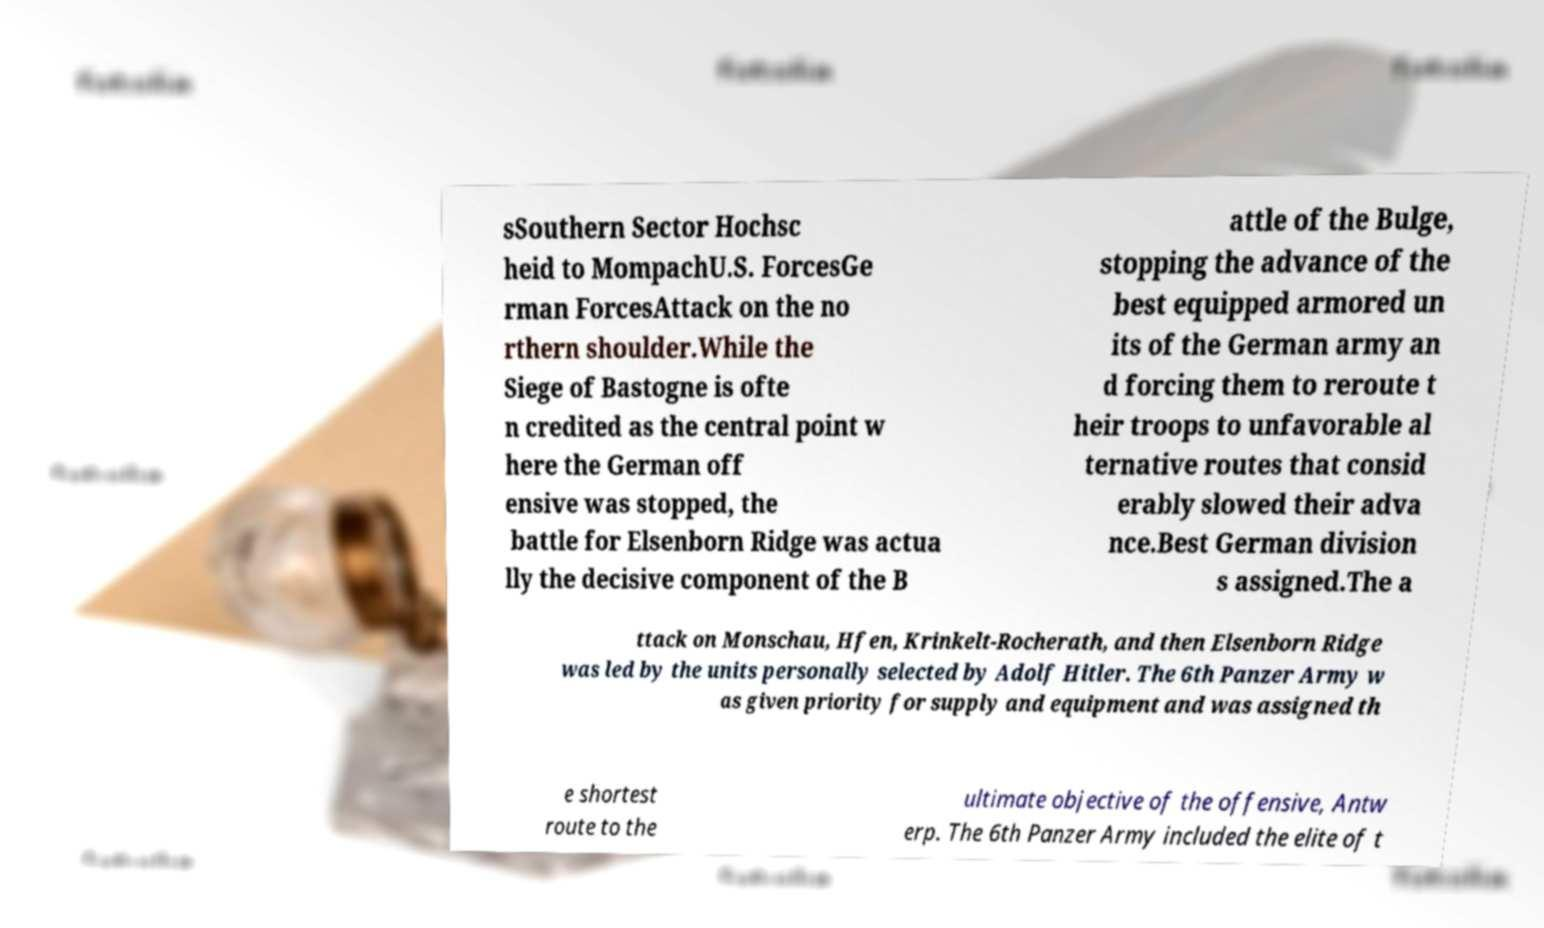Could you extract and type out the text from this image? sSouthern Sector Hochsc heid to MompachU.S. ForcesGe rman ForcesAttack on the no rthern shoulder.While the Siege of Bastogne is ofte n credited as the central point w here the German off ensive was stopped, the battle for Elsenborn Ridge was actua lly the decisive component of the B attle of the Bulge, stopping the advance of the best equipped armored un its of the German army an d forcing them to reroute t heir troops to unfavorable al ternative routes that consid erably slowed their adva nce.Best German division s assigned.The a ttack on Monschau, Hfen, Krinkelt-Rocherath, and then Elsenborn Ridge was led by the units personally selected by Adolf Hitler. The 6th Panzer Army w as given priority for supply and equipment and was assigned th e shortest route to the ultimate objective of the offensive, Antw erp. The 6th Panzer Army included the elite of t 